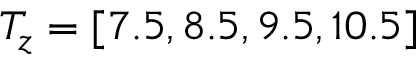Convert formula to latex. <formula><loc_0><loc_0><loc_500><loc_500>T _ { z } = [ 7 . 5 , 8 . 5 , 9 . 5 , 1 0 . 5 ]</formula> 